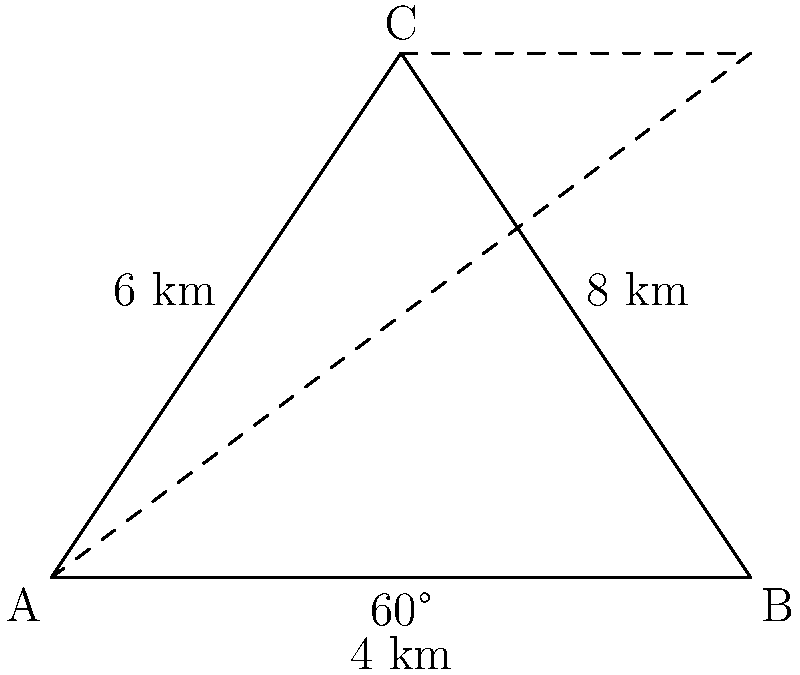In a fragmented habitat, three wildlife corridors form a triangular network connecting patches A, B, and C. The distance between A and B is 8 km, and the angle at B is 60°. A fourth corridor bisects angle C, creating two equal angles. If the length of the corridor from A to C is 6 km, what is the length of the corridor from B to C? Let's approach this step-by-step:

1) We have a triangle ABC with the following known information:
   - AB = 8 km
   - Angle at B = 60°
   - AC = 6 km

2) To find BC, we can use the law of cosines:

   $$BC^2 = AB^2 + AC^2 - 2(AB)(AC)\cos(\angle BAC)$$

3) We know AB and AC, but we need to find angle BAC. We can do this using the law of sines:

   $$\frac{\sin(\angle BAC)}{BC} = \frac{\sin(60°)}{AC}$$

4) Rearranging this:

   $$\sin(\angle BAC) = \frac{AC \sin(60°)}{BC}$$

5) We don't know BC yet, but we can express it in terms of angle BAC using the law of cosines:

   $$BC^2 = 8^2 + 6^2 - 2(8)(6)\cos(\angle BAC)$$
   $$BC^2 = 64 + 36 - 96\cos(\angle BAC)$$

6) Substituting this into our sin(BAC) equation:

   $$\sin(\angle BAC) = \frac{6 \sin(60°)}{\sqrt{100 - 96\cos(\angle BAC)}}$$

7) This equation can be solved numerically to give:

   $$\angle BAC \approx 53.13°$$

8) Now we can use the law of cosines to find BC:

   $$BC^2 = 8^2 + 6^2 - 2(8)(6)\cos(53.13°)$$
   $$BC^2 = 64 + 36 - 96(0.6)$$
   $$BC^2 = 42.4$$
   $$BC \approx 6.51 \text{ km}$$

Therefore, the length of the corridor from B to C is approximately 6.51 km.
Answer: 6.51 km 